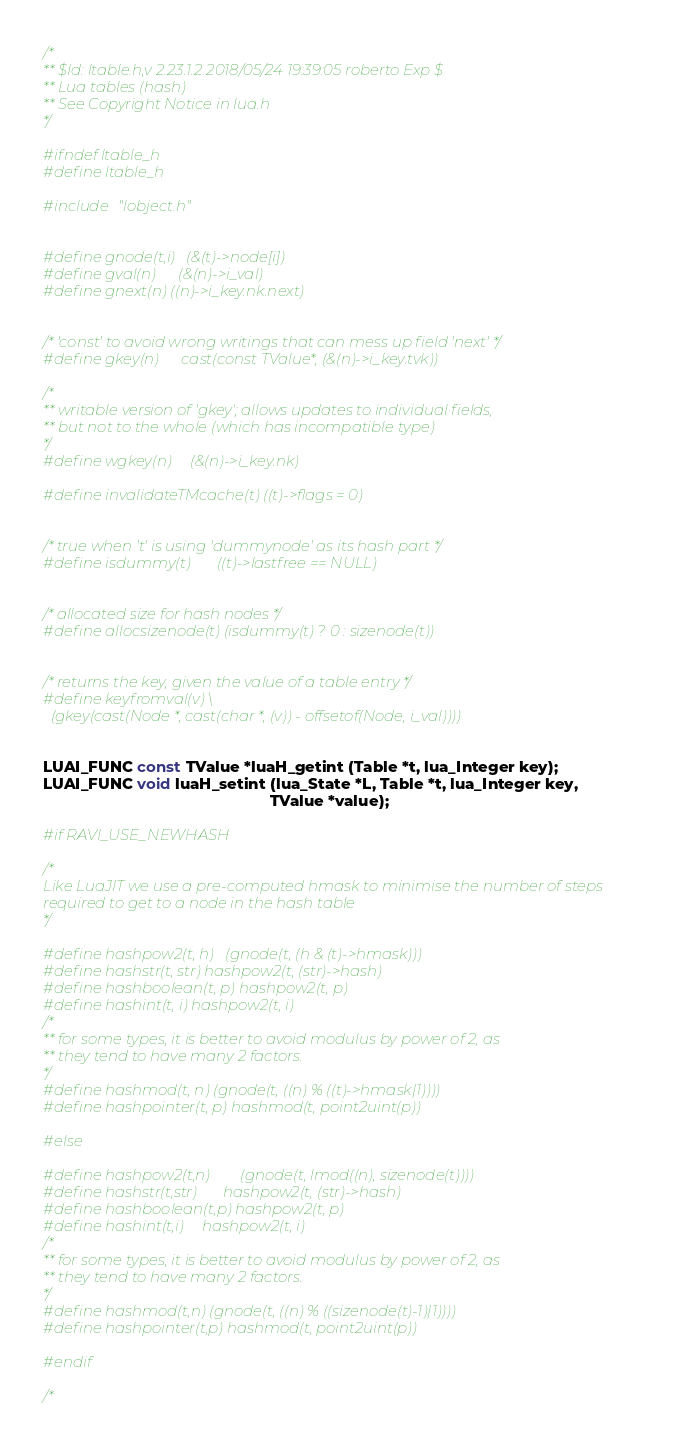<code> <loc_0><loc_0><loc_500><loc_500><_C_>/*
** $Id: ltable.h,v 2.23.1.2 2018/05/24 19:39:05 roberto Exp $
** Lua tables (hash)
** See Copyright Notice in lua.h
*/

#ifndef ltable_h
#define ltable_h

#include "lobject.h"


#define gnode(t,i)	(&(t)->node[i])
#define gval(n)		(&(n)->i_val)
#define gnext(n)	((n)->i_key.nk.next)


/* 'const' to avoid wrong writings that can mess up field 'next' */
#define gkey(n)		cast(const TValue*, (&(n)->i_key.tvk))

/*
** writable version of 'gkey'; allows updates to individual fields,
** but not to the whole (which has incompatible type)
*/
#define wgkey(n)		(&(n)->i_key.nk)

#define invalidateTMcache(t)	((t)->flags = 0)


/* true when 't' is using 'dummynode' as its hash part */
#define isdummy(t)		((t)->lastfree == NULL)


/* allocated size for hash nodes */
#define allocsizenode(t)	(isdummy(t) ? 0 : sizenode(t))


/* returns the key, given the value of a table entry */
#define keyfromval(v) \
  (gkey(cast(Node *, cast(char *, (v)) - offsetof(Node, i_val))))


LUAI_FUNC const TValue *luaH_getint (Table *t, lua_Integer key);
LUAI_FUNC void luaH_setint (lua_State *L, Table *t, lua_Integer key,
                                                    TValue *value);

#if RAVI_USE_NEWHASH

/* 
Like LuaJIT we use a pre-computed hmask to minimise the number of steps
required to get to a node in the hash table
*/

#define hashpow2(t, h)	(gnode(t, (h & (t)->hmask)))
#define hashstr(t, str) hashpow2(t, (str)->hash)
#define hashboolean(t, p) hashpow2(t, p)
#define hashint(t, i) hashpow2(t, i)
/*
** for some types, it is better to avoid modulus by power of 2, as
** they tend to have many 2 factors.
*/
#define hashmod(t, n) (gnode(t, ((n) % ((t)->hmask|1))))
#define hashpointer(t, p) hashmod(t, point2uint(p))

#else 

#define hashpow2(t,n)		(gnode(t, lmod((n), sizenode(t))))
#define hashstr(t,str)		hashpow2(t, (str)->hash)
#define hashboolean(t,p)	hashpow2(t, p)
#define hashint(t,i)		hashpow2(t, i)
/*
** for some types, it is better to avoid modulus by power of 2, as
** they tend to have many 2 factors.
*/
#define hashmod(t,n)	(gnode(t, ((n) % ((sizenode(t)-1)|1))))
#define hashpointer(t,p)	hashmod(t, point2uint(p))

#endif

/*</code> 